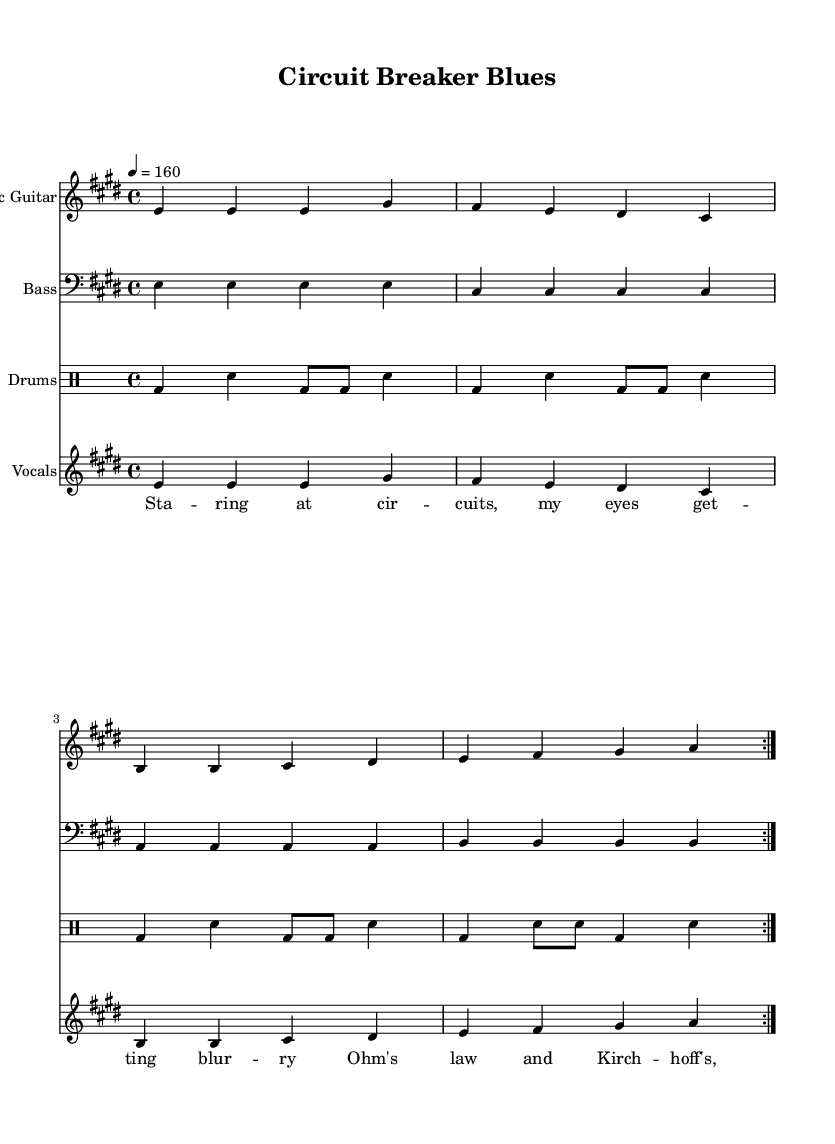What is the key signature of this music? The key signature is indicated by the presence of four sharps (F#, C#, G#, D#) which corresponds to the key of E major.
Answer: E major What is the time signature of this music? The time signature appears at the beginning of the sheet music and shows 4/4, indicating four beats per measure.
Answer: 4/4 What is the tempo marking for this music? The tempo marking is given as 4 = 160, which indicates that there are 160 beats per minute with each quarter note getting one beat.
Answer: 160 How many repetitions are in the electric guitar part? The electric guitar section is marked with "volta 2", meaning it is repeated two times throughout that section.
Answer: 2 What is the musical form of the piece? The format consists of a repeated structure with the electric guitar, bass, and drum parts all repeating the same section, indicative of a verse-chorus format common in pop-punk music.
Answer: Verse-chorus What type of lyrics are present in the song? The lyrics use a playful and frustrated narrative, discussing the struggles with engineering concepts like Ohm's law, which reflects the thematic elements of punk music blended with an academic struggle.
Answer: Playful and frustrated 